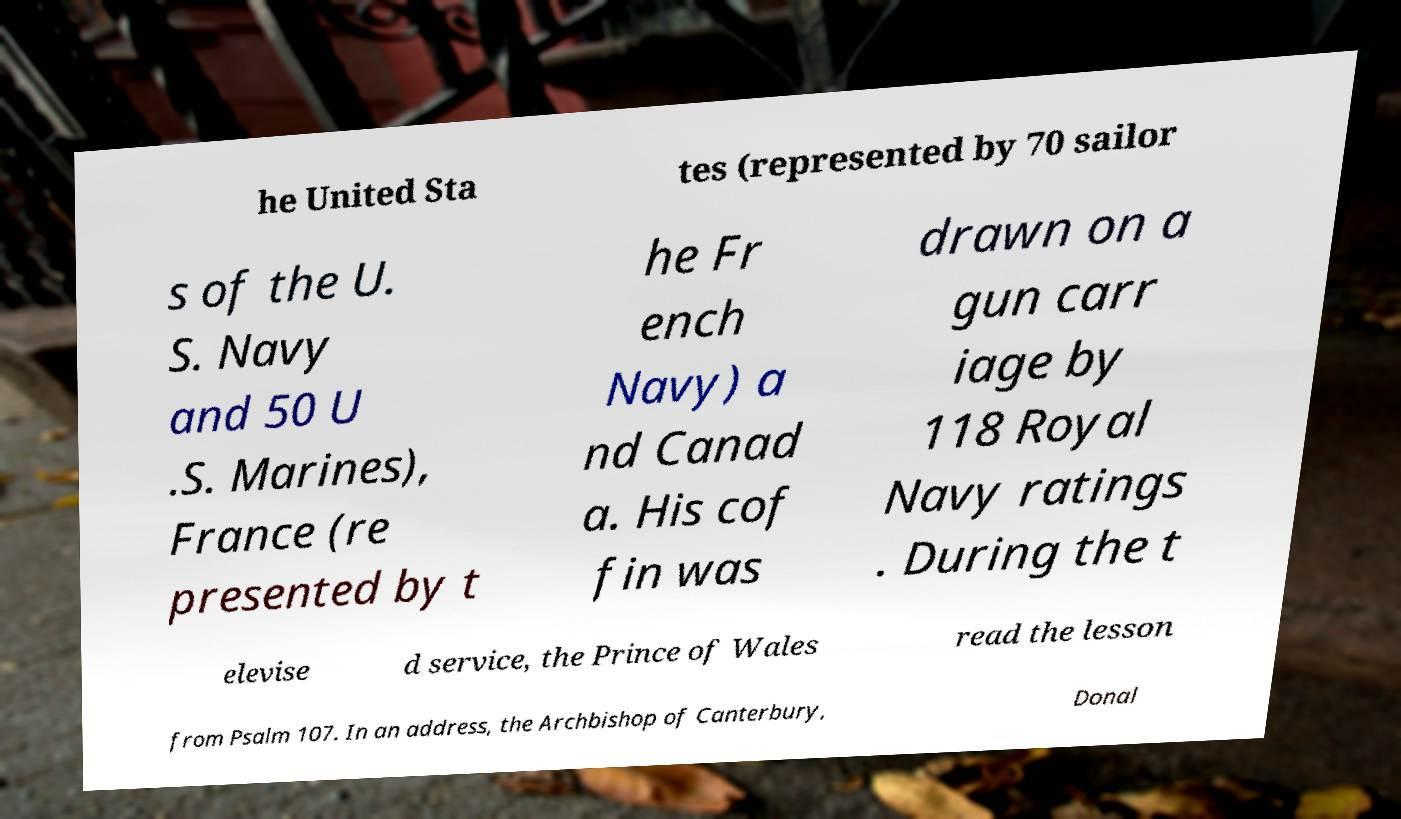What messages or text are displayed in this image? I need them in a readable, typed format. he United Sta tes (represented by 70 sailor s of the U. S. Navy and 50 U .S. Marines), France (re presented by t he Fr ench Navy) a nd Canad a. His cof fin was drawn on a gun carr iage by 118 Royal Navy ratings . During the t elevise d service, the Prince of Wales read the lesson from Psalm 107. In an address, the Archbishop of Canterbury, Donal 